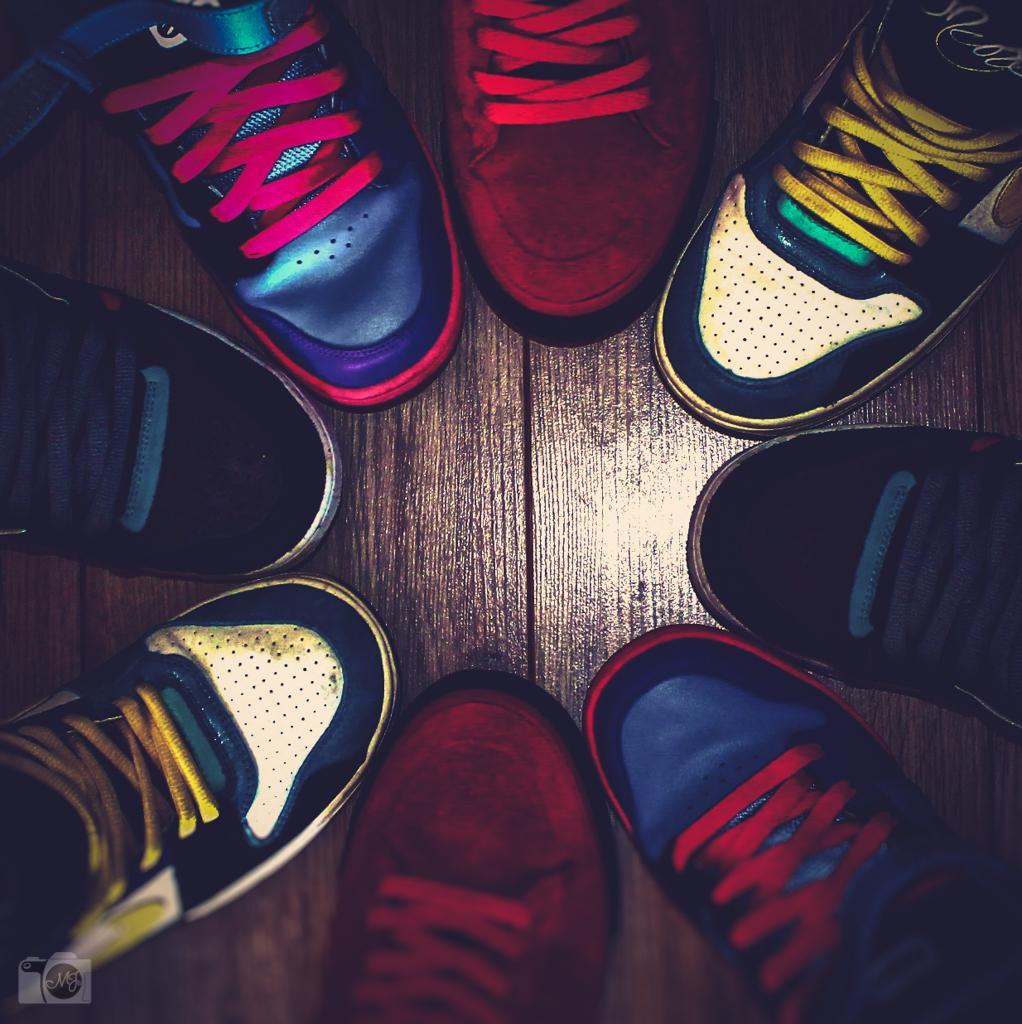Describe this image in one or two sentences. In this image I can see the shoes which are colorful. These shoes are on the brown color surface. 